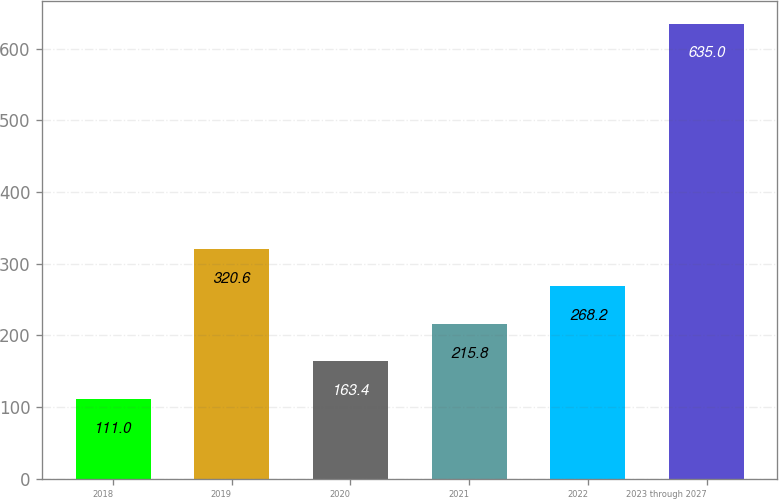<chart> <loc_0><loc_0><loc_500><loc_500><bar_chart><fcel>2018<fcel>2019<fcel>2020<fcel>2021<fcel>2022<fcel>2023 through 2027<nl><fcel>111<fcel>320.6<fcel>163.4<fcel>215.8<fcel>268.2<fcel>635<nl></chart> 